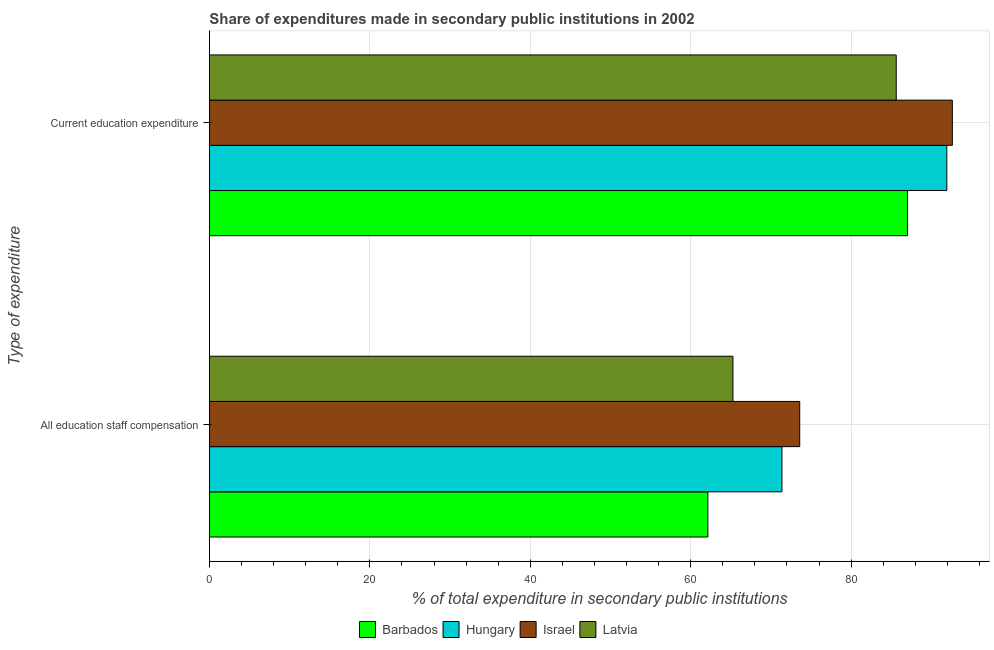How many different coloured bars are there?
Your answer should be very brief. 4. How many groups of bars are there?
Give a very brief answer. 2. Are the number of bars on each tick of the Y-axis equal?
Your response must be concise. Yes. How many bars are there on the 1st tick from the top?
Provide a succinct answer. 4. What is the label of the 2nd group of bars from the top?
Offer a very short reply. All education staff compensation. What is the expenditure in education in Hungary?
Your answer should be very brief. 91.94. Across all countries, what is the maximum expenditure in staff compensation?
Offer a terse response. 73.59. Across all countries, what is the minimum expenditure in staff compensation?
Give a very brief answer. 62.14. In which country was the expenditure in education minimum?
Make the answer very short. Latvia. What is the total expenditure in staff compensation in the graph?
Offer a terse response. 272.39. What is the difference between the expenditure in staff compensation in Barbados and that in Israel?
Provide a short and direct response. -11.45. What is the difference between the expenditure in staff compensation in Barbados and the expenditure in education in Hungary?
Offer a very short reply. -29.79. What is the average expenditure in education per country?
Offer a terse response. 89.31. What is the difference between the expenditure in education and expenditure in staff compensation in Latvia?
Keep it short and to the point. 20.36. What is the ratio of the expenditure in education in Latvia to that in Israel?
Provide a short and direct response. 0.92. Is the expenditure in staff compensation in Latvia less than that in Barbados?
Your answer should be very brief. No. In how many countries, is the expenditure in education greater than the average expenditure in education taken over all countries?
Your response must be concise. 2. What does the 2nd bar from the top in All education staff compensation represents?
Ensure brevity in your answer.  Israel. What does the 1st bar from the bottom in Current education expenditure represents?
Your answer should be very brief. Barbados. How many bars are there?
Give a very brief answer. 8. How many countries are there in the graph?
Keep it short and to the point. 4. What is the difference between two consecutive major ticks on the X-axis?
Your answer should be very brief. 20. Does the graph contain any zero values?
Your response must be concise. No. Where does the legend appear in the graph?
Offer a very short reply. Bottom center. How many legend labels are there?
Ensure brevity in your answer.  4. How are the legend labels stacked?
Provide a succinct answer. Horizontal. What is the title of the graph?
Give a very brief answer. Share of expenditures made in secondary public institutions in 2002. Does "Sierra Leone" appear as one of the legend labels in the graph?
Keep it short and to the point. No. What is the label or title of the X-axis?
Offer a terse response. % of total expenditure in secondary public institutions. What is the label or title of the Y-axis?
Your answer should be compact. Type of expenditure. What is the % of total expenditure in secondary public institutions in Barbados in All education staff compensation?
Provide a succinct answer. 62.14. What is the % of total expenditure in secondary public institutions in Hungary in All education staff compensation?
Provide a succinct answer. 71.38. What is the % of total expenditure in secondary public institutions of Israel in All education staff compensation?
Keep it short and to the point. 73.59. What is the % of total expenditure in secondary public institutions in Latvia in All education staff compensation?
Offer a terse response. 65.27. What is the % of total expenditure in secondary public institutions of Barbados in Current education expenditure?
Offer a very short reply. 87.04. What is the % of total expenditure in secondary public institutions of Hungary in Current education expenditure?
Offer a very short reply. 91.94. What is the % of total expenditure in secondary public institutions of Israel in Current education expenditure?
Offer a very short reply. 92.62. What is the % of total expenditure in secondary public institutions of Latvia in Current education expenditure?
Give a very brief answer. 85.63. Across all Type of expenditure, what is the maximum % of total expenditure in secondary public institutions in Barbados?
Keep it short and to the point. 87.04. Across all Type of expenditure, what is the maximum % of total expenditure in secondary public institutions in Hungary?
Offer a terse response. 91.94. Across all Type of expenditure, what is the maximum % of total expenditure in secondary public institutions of Israel?
Keep it short and to the point. 92.62. Across all Type of expenditure, what is the maximum % of total expenditure in secondary public institutions of Latvia?
Offer a very short reply. 85.63. Across all Type of expenditure, what is the minimum % of total expenditure in secondary public institutions of Barbados?
Offer a terse response. 62.14. Across all Type of expenditure, what is the minimum % of total expenditure in secondary public institutions of Hungary?
Your answer should be very brief. 71.38. Across all Type of expenditure, what is the minimum % of total expenditure in secondary public institutions of Israel?
Give a very brief answer. 73.59. Across all Type of expenditure, what is the minimum % of total expenditure in secondary public institutions in Latvia?
Provide a succinct answer. 65.27. What is the total % of total expenditure in secondary public institutions in Barbados in the graph?
Make the answer very short. 149.18. What is the total % of total expenditure in secondary public institutions in Hungary in the graph?
Offer a very short reply. 163.32. What is the total % of total expenditure in secondary public institutions of Israel in the graph?
Ensure brevity in your answer.  166.22. What is the total % of total expenditure in secondary public institutions of Latvia in the graph?
Provide a succinct answer. 150.9. What is the difference between the % of total expenditure in secondary public institutions in Barbados in All education staff compensation and that in Current education expenditure?
Make the answer very short. -24.9. What is the difference between the % of total expenditure in secondary public institutions in Hungary in All education staff compensation and that in Current education expenditure?
Make the answer very short. -20.56. What is the difference between the % of total expenditure in secondary public institutions in Israel in All education staff compensation and that in Current education expenditure?
Your response must be concise. -19.03. What is the difference between the % of total expenditure in secondary public institutions in Latvia in All education staff compensation and that in Current education expenditure?
Give a very brief answer. -20.36. What is the difference between the % of total expenditure in secondary public institutions of Barbados in All education staff compensation and the % of total expenditure in secondary public institutions of Hungary in Current education expenditure?
Keep it short and to the point. -29.79. What is the difference between the % of total expenditure in secondary public institutions in Barbados in All education staff compensation and the % of total expenditure in secondary public institutions in Israel in Current education expenditure?
Your response must be concise. -30.48. What is the difference between the % of total expenditure in secondary public institutions in Barbados in All education staff compensation and the % of total expenditure in secondary public institutions in Latvia in Current education expenditure?
Offer a very short reply. -23.49. What is the difference between the % of total expenditure in secondary public institutions of Hungary in All education staff compensation and the % of total expenditure in secondary public institutions of Israel in Current education expenditure?
Your answer should be very brief. -21.24. What is the difference between the % of total expenditure in secondary public institutions in Hungary in All education staff compensation and the % of total expenditure in secondary public institutions in Latvia in Current education expenditure?
Ensure brevity in your answer.  -14.25. What is the difference between the % of total expenditure in secondary public institutions of Israel in All education staff compensation and the % of total expenditure in secondary public institutions of Latvia in Current education expenditure?
Provide a short and direct response. -12.03. What is the average % of total expenditure in secondary public institutions in Barbados per Type of expenditure?
Your response must be concise. 74.59. What is the average % of total expenditure in secondary public institutions in Hungary per Type of expenditure?
Your answer should be very brief. 81.66. What is the average % of total expenditure in secondary public institutions in Israel per Type of expenditure?
Make the answer very short. 83.11. What is the average % of total expenditure in secondary public institutions of Latvia per Type of expenditure?
Provide a short and direct response. 75.45. What is the difference between the % of total expenditure in secondary public institutions in Barbados and % of total expenditure in secondary public institutions in Hungary in All education staff compensation?
Provide a succinct answer. -9.24. What is the difference between the % of total expenditure in secondary public institutions of Barbados and % of total expenditure in secondary public institutions of Israel in All education staff compensation?
Your answer should be very brief. -11.45. What is the difference between the % of total expenditure in secondary public institutions of Barbados and % of total expenditure in secondary public institutions of Latvia in All education staff compensation?
Ensure brevity in your answer.  -3.13. What is the difference between the % of total expenditure in secondary public institutions of Hungary and % of total expenditure in secondary public institutions of Israel in All education staff compensation?
Your answer should be compact. -2.21. What is the difference between the % of total expenditure in secondary public institutions of Hungary and % of total expenditure in secondary public institutions of Latvia in All education staff compensation?
Provide a succinct answer. 6.11. What is the difference between the % of total expenditure in secondary public institutions of Israel and % of total expenditure in secondary public institutions of Latvia in All education staff compensation?
Your answer should be very brief. 8.33. What is the difference between the % of total expenditure in secondary public institutions in Barbados and % of total expenditure in secondary public institutions in Hungary in Current education expenditure?
Ensure brevity in your answer.  -4.89. What is the difference between the % of total expenditure in secondary public institutions of Barbados and % of total expenditure in secondary public institutions of Israel in Current education expenditure?
Your answer should be compact. -5.58. What is the difference between the % of total expenditure in secondary public institutions of Barbados and % of total expenditure in secondary public institutions of Latvia in Current education expenditure?
Offer a very short reply. 1.41. What is the difference between the % of total expenditure in secondary public institutions of Hungary and % of total expenditure in secondary public institutions of Israel in Current education expenditure?
Offer a very short reply. -0.69. What is the difference between the % of total expenditure in secondary public institutions in Hungary and % of total expenditure in secondary public institutions in Latvia in Current education expenditure?
Your answer should be compact. 6.31. What is the difference between the % of total expenditure in secondary public institutions of Israel and % of total expenditure in secondary public institutions of Latvia in Current education expenditure?
Offer a very short reply. 7. What is the ratio of the % of total expenditure in secondary public institutions of Barbados in All education staff compensation to that in Current education expenditure?
Your answer should be compact. 0.71. What is the ratio of the % of total expenditure in secondary public institutions in Hungary in All education staff compensation to that in Current education expenditure?
Offer a terse response. 0.78. What is the ratio of the % of total expenditure in secondary public institutions in Israel in All education staff compensation to that in Current education expenditure?
Offer a very short reply. 0.79. What is the ratio of the % of total expenditure in secondary public institutions in Latvia in All education staff compensation to that in Current education expenditure?
Provide a succinct answer. 0.76. What is the difference between the highest and the second highest % of total expenditure in secondary public institutions in Barbados?
Offer a very short reply. 24.9. What is the difference between the highest and the second highest % of total expenditure in secondary public institutions of Hungary?
Ensure brevity in your answer.  20.56. What is the difference between the highest and the second highest % of total expenditure in secondary public institutions of Israel?
Offer a very short reply. 19.03. What is the difference between the highest and the second highest % of total expenditure in secondary public institutions in Latvia?
Make the answer very short. 20.36. What is the difference between the highest and the lowest % of total expenditure in secondary public institutions in Barbados?
Offer a very short reply. 24.9. What is the difference between the highest and the lowest % of total expenditure in secondary public institutions of Hungary?
Make the answer very short. 20.56. What is the difference between the highest and the lowest % of total expenditure in secondary public institutions in Israel?
Give a very brief answer. 19.03. What is the difference between the highest and the lowest % of total expenditure in secondary public institutions in Latvia?
Your answer should be very brief. 20.36. 